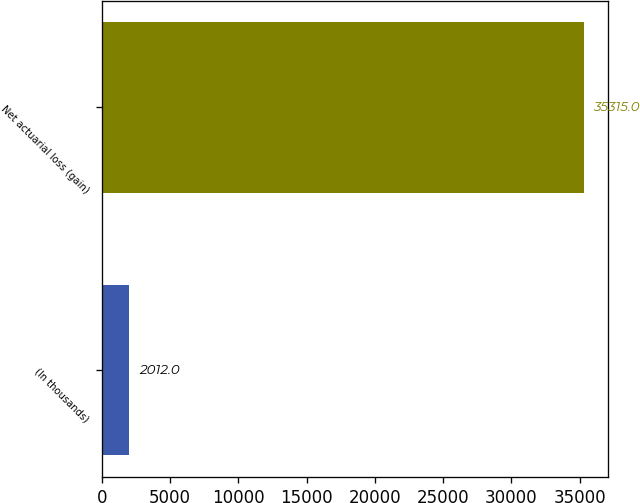Convert chart to OTSL. <chart><loc_0><loc_0><loc_500><loc_500><bar_chart><fcel>(In thousands)<fcel>Net actuarial loss (gain)<nl><fcel>2012<fcel>35315<nl></chart> 